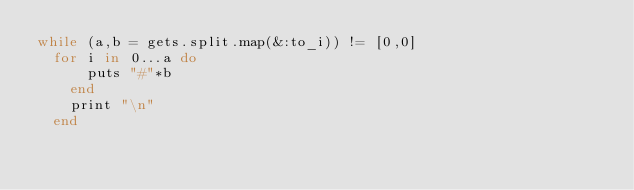<code> <loc_0><loc_0><loc_500><loc_500><_Ruby_>while (a,b = gets.split.map(&:to_i)) != [0,0] 
  for i in 0...a do 
      puts "#"*b
    end
    print "\n"
  end
</code> 